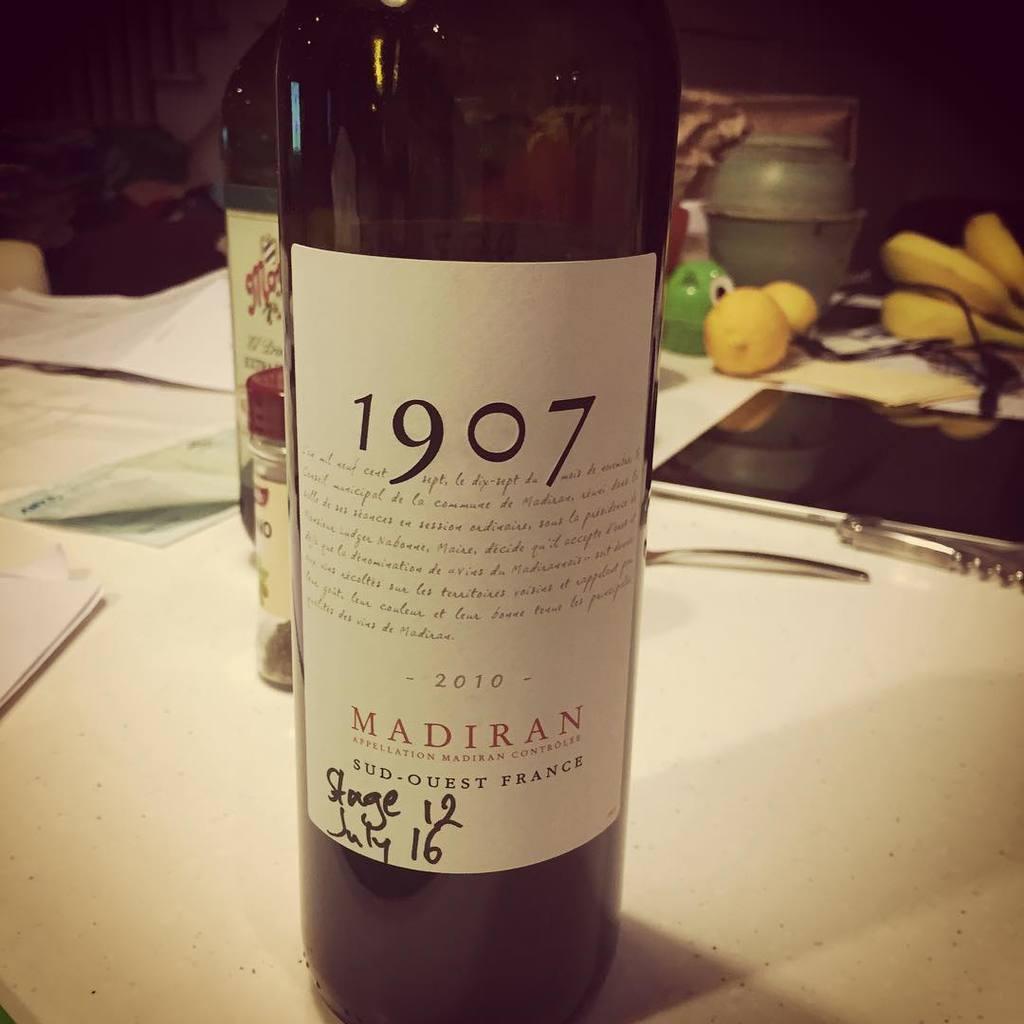Is this red or white wine?
Make the answer very short. Red. 